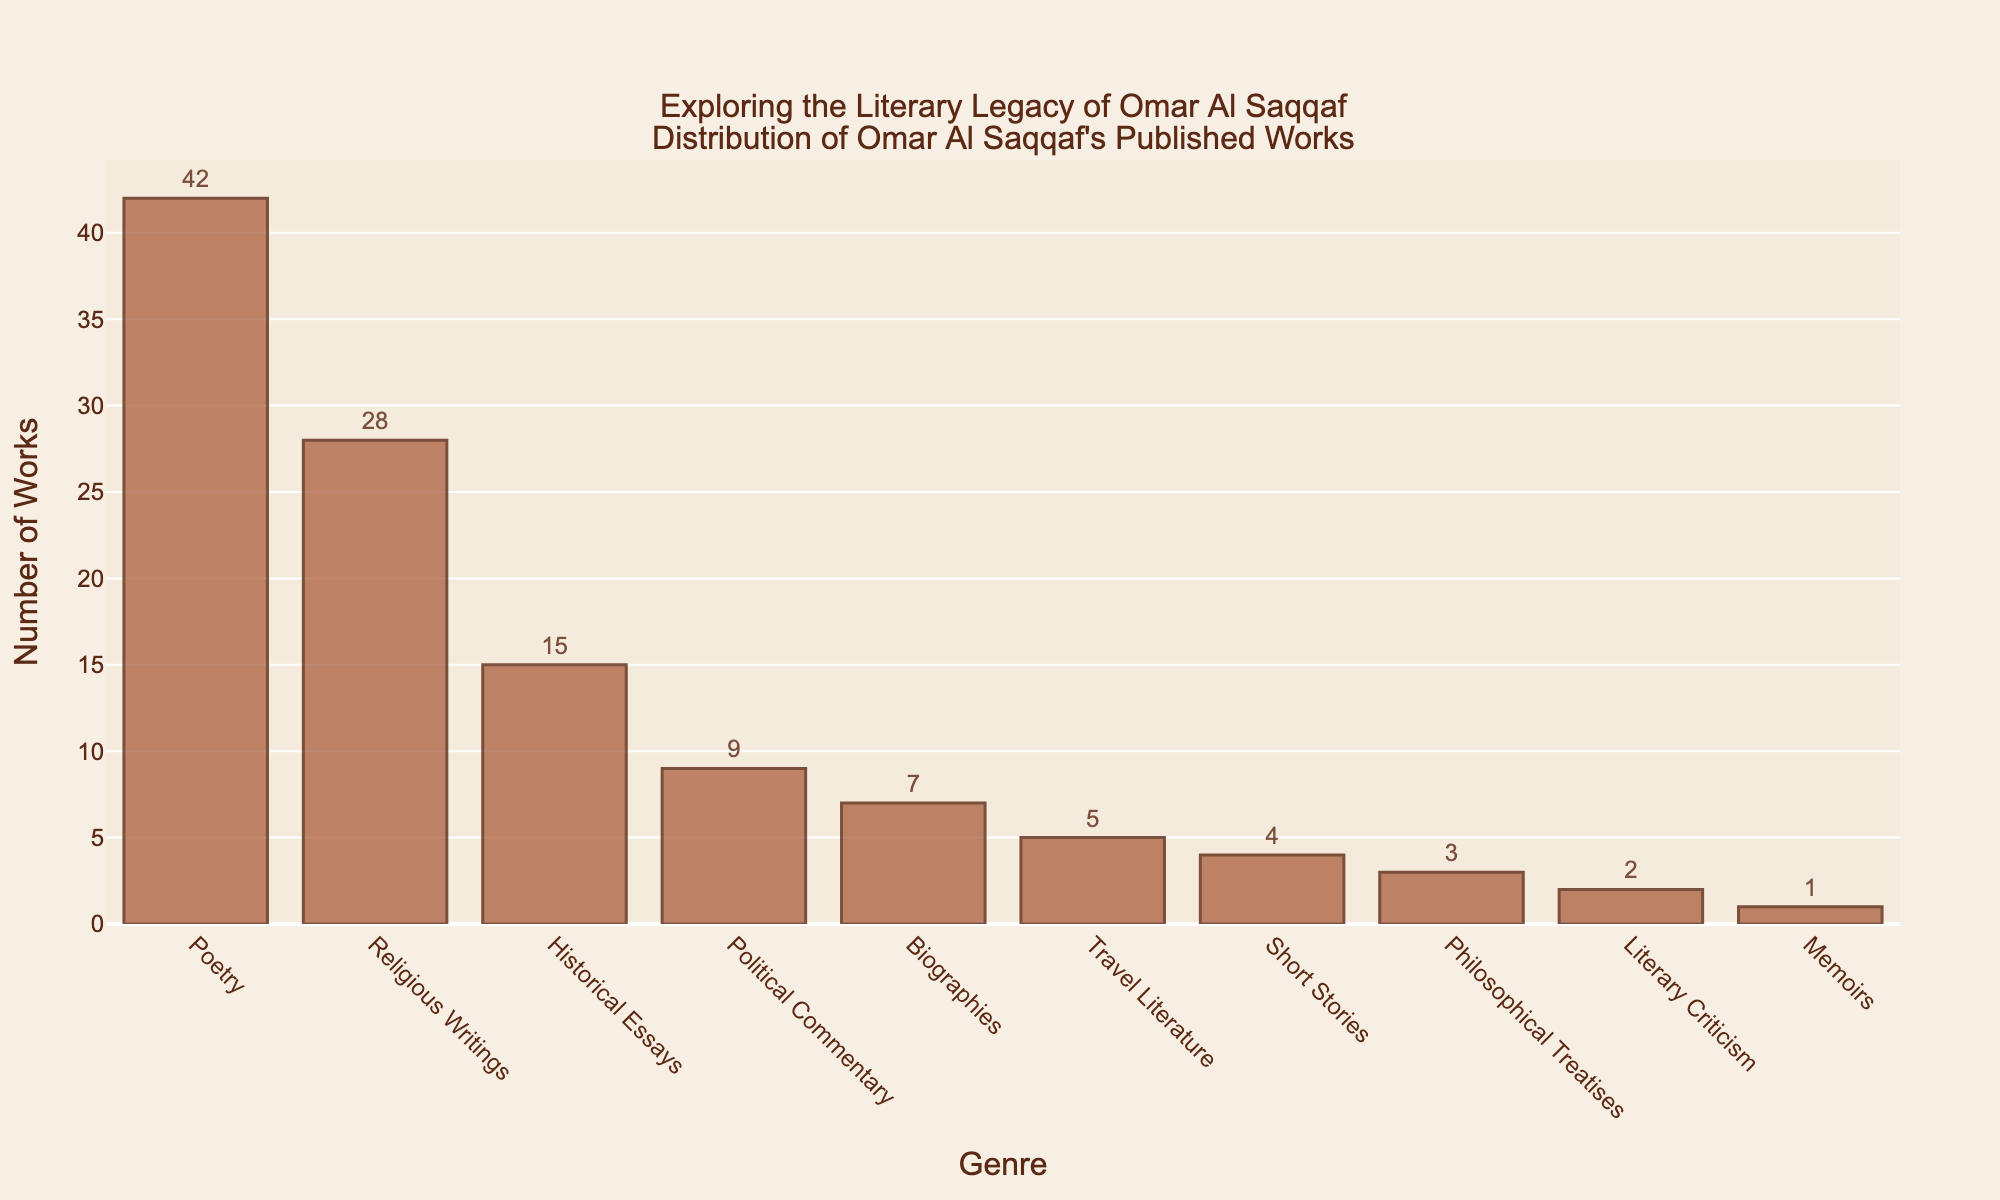Which genre has the highest number of published works? The height of the bar representing "Poetry" is the tallest in the chart. Thus, Poetry has the highest number of published works, which is 42.
Answer: Poetry How many more works are there in Religious Writings compared to Biographies? Religious Writings have 28 works, and Biographies have 7 works. The difference is 28 - 7 = 21 works.
Answer: 21 Which genres have fewer than 10 published works? From the chart, Political Commentary (9), Biographies (7), Travel Literature (5), Short Stories (4), Philosophical Treatises (3), Literary Criticism (2), and Memoirs (1) have fewer than 10 published works.
Answer: Political Commentary, Biographies, Travel Literature, Short Stories, Philosophical Treatises, Literary Criticism, Memoirs What is the total number of published works in Poetry and Religious Writings combined? Poetry has 42 works, and Religious Writings have 28 works. The total is 42 + 28 = 70 works.
Answer: 70 How does the number of works in Historical Essays compare to Political Commentary? Historical Essays have 15 works and Political Commentary has 9 works. Historical Essays have more works (15 > 9).
Answer: Historical Essays have more What is the average number of works across all genres? Sum the number of works in all genres: 42 + 28 + 15 + 9 + 7 + 5 + 4 + 3 + 2 + 1 = 116. There are 10 genres, so the average is 116 / 10 = 11.6 works.
Answer: 11.6 Are there any genres with exactly the same number of works? The chart does not show any two bars with the exact same height, indicating no genres have exactly the same number of works.
Answer: No What is the ratio of Short Stories to Philosophical Treatises published? Short Stories have 4 works, and Philosophical Treatises have 3 works. The ratio is 4:3.
Answer: 4:3 Which genres have the least and the most number of works? The shortest bar in the chart represents Memoirs with 1 work, and the tallest bar represents Poetry with 42 works.
Answer: Memoirs (least), Poetry (most) By how much does the sum of works in Biographies, Travel Literature, and Short Stories exceed the number of works in Poetry? The sum of Biographies (7), Travel Literature (5), and Short Stories (4) is 7 + 5 + 4 = 16. Poetry has 42 works. Thus, 42 - 16 = 26 works more in Poetry.
Answer: Poetry exceeds by 26 